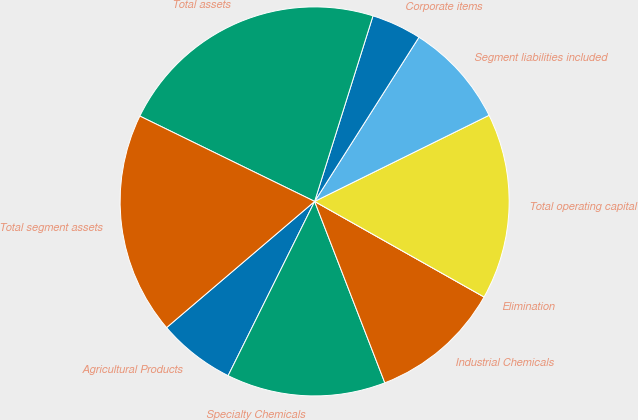<chart> <loc_0><loc_0><loc_500><loc_500><pie_chart><fcel>Agricultural Products<fcel>Specialty Chemicals<fcel>Industrial Chemicals<fcel>Elimination<fcel>Total operating capital<fcel>Segment liabilities included<fcel>Corporate items<fcel>Total assets<fcel>Total segment assets<nl><fcel>6.43%<fcel>13.21%<fcel>10.95%<fcel>0.0%<fcel>15.47%<fcel>8.69%<fcel>4.16%<fcel>22.62%<fcel>18.46%<nl></chart> 